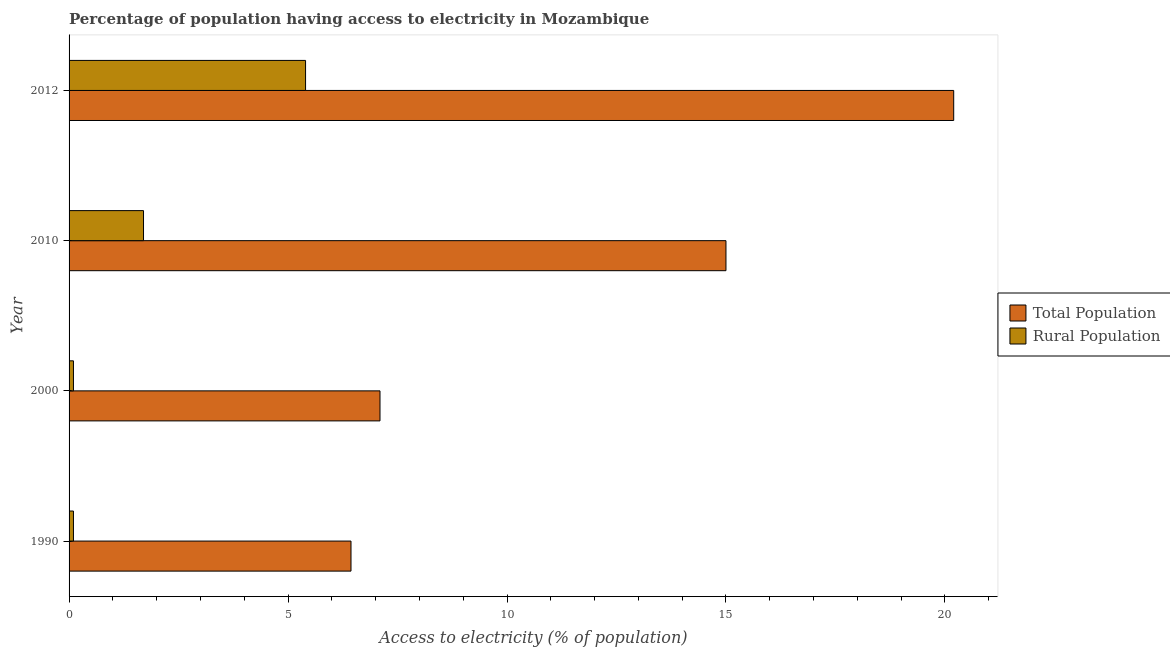Are the number of bars per tick equal to the number of legend labels?
Offer a very short reply. Yes. In how many cases, is the number of bars for a given year not equal to the number of legend labels?
Keep it short and to the point. 0. What is the percentage of population having access to electricity in 1990?
Offer a terse response. 6.44. Across all years, what is the maximum percentage of population having access to electricity?
Your response must be concise. 20.2. Across all years, what is the minimum percentage of population having access to electricity?
Ensure brevity in your answer.  6.44. In which year was the percentage of population having access to electricity maximum?
Make the answer very short. 2012. What is the total percentage of rural population having access to electricity in the graph?
Your answer should be compact. 7.3. What is the difference between the percentage of population having access to electricity in 2000 and that in 2012?
Make the answer very short. -13.1. What is the difference between the percentage of rural population having access to electricity in 2000 and the percentage of population having access to electricity in 2010?
Offer a very short reply. -14.9. What is the average percentage of population having access to electricity per year?
Provide a short and direct response. 12.18. In the year 2010, what is the difference between the percentage of population having access to electricity and percentage of rural population having access to electricity?
Provide a succinct answer. 13.3. What is the ratio of the percentage of rural population having access to electricity in 1990 to that in 2010?
Ensure brevity in your answer.  0.06. Is the percentage of population having access to electricity in 1990 less than that in 2012?
Your answer should be very brief. Yes. What is the difference between the highest and the second highest percentage of population having access to electricity?
Give a very brief answer. 5.2. What is the difference between the highest and the lowest percentage of population having access to electricity?
Offer a very short reply. 13.76. In how many years, is the percentage of rural population having access to electricity greater than the average percentage of rural population having access to electricity taken over all years?
Your answer should be very brief. 1. Is the sum of the percentage of rural population having access to electricity in 1990 and 2010 greater than the maximum percentage of population having access to electricity across all years?
Provide a succinct answer. No. What does the 1st bar from the top in 1990 represents?
Your answer should be compact. Rural Population. What does the 1st bar from the bottom in 1990 represents?
Provide a short and direct response. Total Population. How many years are there in the graph?
Your answer should be compact. 4. Are the values on the major ticks of X-axis written in scientific E-notation?
Your answer should be compact. No. Does the graph contain any zero values?
Your response must be concise. No. What is the title of the graph?
Your answer should be very brief. Percentage of population having access to electricity in Mozambique. Does "National Tourists" appear as one of the legend labels in the graph?
Ensure brevity in your answer.  No. What is the label or title of the X-axis?
Provide a short and direct response. Access to electricity (% of population). What is the Access to electricity (% of population) of Total Population in 1990?
Ensure brevity in your answer.  6.44. What is the Access to electricity (% of population) in Total Population in 2000?
Provide a succinct answer. 7.1. What is the Access to electricity (% of population) in Rural Population in 2000?
Give a very brief answer. 0.1. What is the Access to electricity (% of population) in Total Population in 2012?
Provide a short and direct response. 20.2. What is the Access to electricity (% of population) of Rural Population in 2012?
Keep it short and to the point. 5.4. Across all years, what is the maximum Access to electricity (% of population) of Total Population?
Offer a very short reply. 20.2. Across all years, what is the maximum Access to electricity (% of population) in Rural Population?
Offer a very short reply. 5.4. Across all years, what is the minimum Access to electricity (% of population) in Total Population?
Your answer should be very brief. 6.44. Across all years, what is the minimum Access to electricity (% of population) in Rural Population?
Keep it short and to the point. 0.1. What is the total Access to electricity (% of population) in Total Population in the graph?
Your answer should be very brief. 48.74. What is the total Access to electricity (% of population) in Rural Population in the graph?
Your response must be concise. 7.3. What is the difference between the Access to electricity (% of population) in Total Population in 1990 and that in 2000?
Ensure brevity in your answer.  -0.66. What is the difference between the Access to electricity (% of population) of Rural Population in 1990 and that in 2000?
Provide a short and direct response. 0. What is the difference between the Access to electricity (% of population) of Total Population in 1990 and that in 2010?
Offer a very short reply. -8.56. What is the difference between the Access to electricity (% of population) in Total Population in 1990 and that in 2012?
Provide a succinct answer. -13.76. What is the difference between the Access to electricity (% of population) in Rural Population in 2000 and that in 2012?
Keep it short and to the point. -5.3. What is the difference between the Access to electricity (% of population) in Total Population in 2010 and that in 2012?
Offer a terse response. -5.2. What is the difference between the Access to electricity (% of population) in Total Population in 1990 and the Access to electricity (% of population) in Rural Population in 2000?
Make the answer very short. 6.34. What is the difference between the Access to electricity (% of population) in Total Population in 1990 and the Access to electricity (% of population) in Rural Population in 2010?
Provide a succinct answer. 4.74. What is the difference between the Access to electricity (% of population) of Total Population in 1990 and the Access to electricity (% of population) of Rural Population in 2012?
Your answer should be very brief. 1.04. What is the difference between the Access to electricity (% of population) in Total Population in 2000 and the Access to electricity (% of population) in Rural Population in 2010?
Your answer should be very brief. 5.4. What is the difference between the Access to electricity (% of population) of Total Population in 2000 and the Access to electricity (% of population) of Rural Population in 2012?
Offer a terse response. 1.7. What is the average Access to electricity (% of population) of Total Population per year?
Your response must be concise. 12.18. What is the average Access to electricity (% of population) in Rural Population per year?
Offer a very short reply. 1.82. In the year 1990, what is the difference between the Access to electricity (% of population) in Total Population and Access to electricity (% of population) in Rural Population?
Offer a very short reply. 6.34. In the year 2000, what is the difference between the Access to electricity (% of population) of Total Population and Access to electricity (% of population) of Rural Population?
Your response must be concise. 7. In the year 2010, what is the difference between the Access to electricity (% of population) in Total Population and Access to electricity (% of population) in Rural Population?
Give a very brief answer. 13.3. What is the ratio of the Access to electricity (% of population) of Total Population in 1990 to that in 2000?
Offer a very short reply. 0.91. What is the ratio of the Access to electricity (% of population) in Total Population in 1990 to that in 2010?
Provide a short and direct response. 0.43. What is the ratio of the Access to electricity (% of population) of Rural Population in 1990 to that in 2010?
Provide a short and direct response. 0.06. What is the ratio of the Access to electricity (% of population) of Total Population in 1990 to that in 2012?
Give a very brief answer. 0.32. What is the ratio of the Access to electricity (% of population) of Rural Population in 1990 to that in 2012?
Provide a short and direct response. 0.02. What is the ratio of the Access to electricity (% of population) in Total Population in 2000 to that in 2010?
Give a very brief answer. 0.47. What is the ratio of the Access to electricity (% of population) in Rural Population in 2000 to that in 2010?
Give a very brief answer. 0.06. What is the ratio of the Access to electricity (% of population) of Total Population in 2000 to that in 2012?
Provide a short and direct response. 0.35. What is the ratio of the Access to electricity (% of population) in Rural Population in 2000 to that in 2012?
Your answer should be very brief. 0.02. What is the ratio of the Access to electricity (% of population) in Total Population in 2010 to that in 2012?
Keep it short and to the point. 0.74. What is the ratio of the Access to electricity (% of population) in Rural Population in 2010 to that in 2012?
Offer a very short reply. 0.31. What is the difference between the highest and the lowest Access to electricity (% of population) in Total Population?
Offer a terse response. 13.76. What is the difference between the highest and the lowest Access to electricity (% of population) in Rural Population?
Your answer should be very brief. 5.3. 